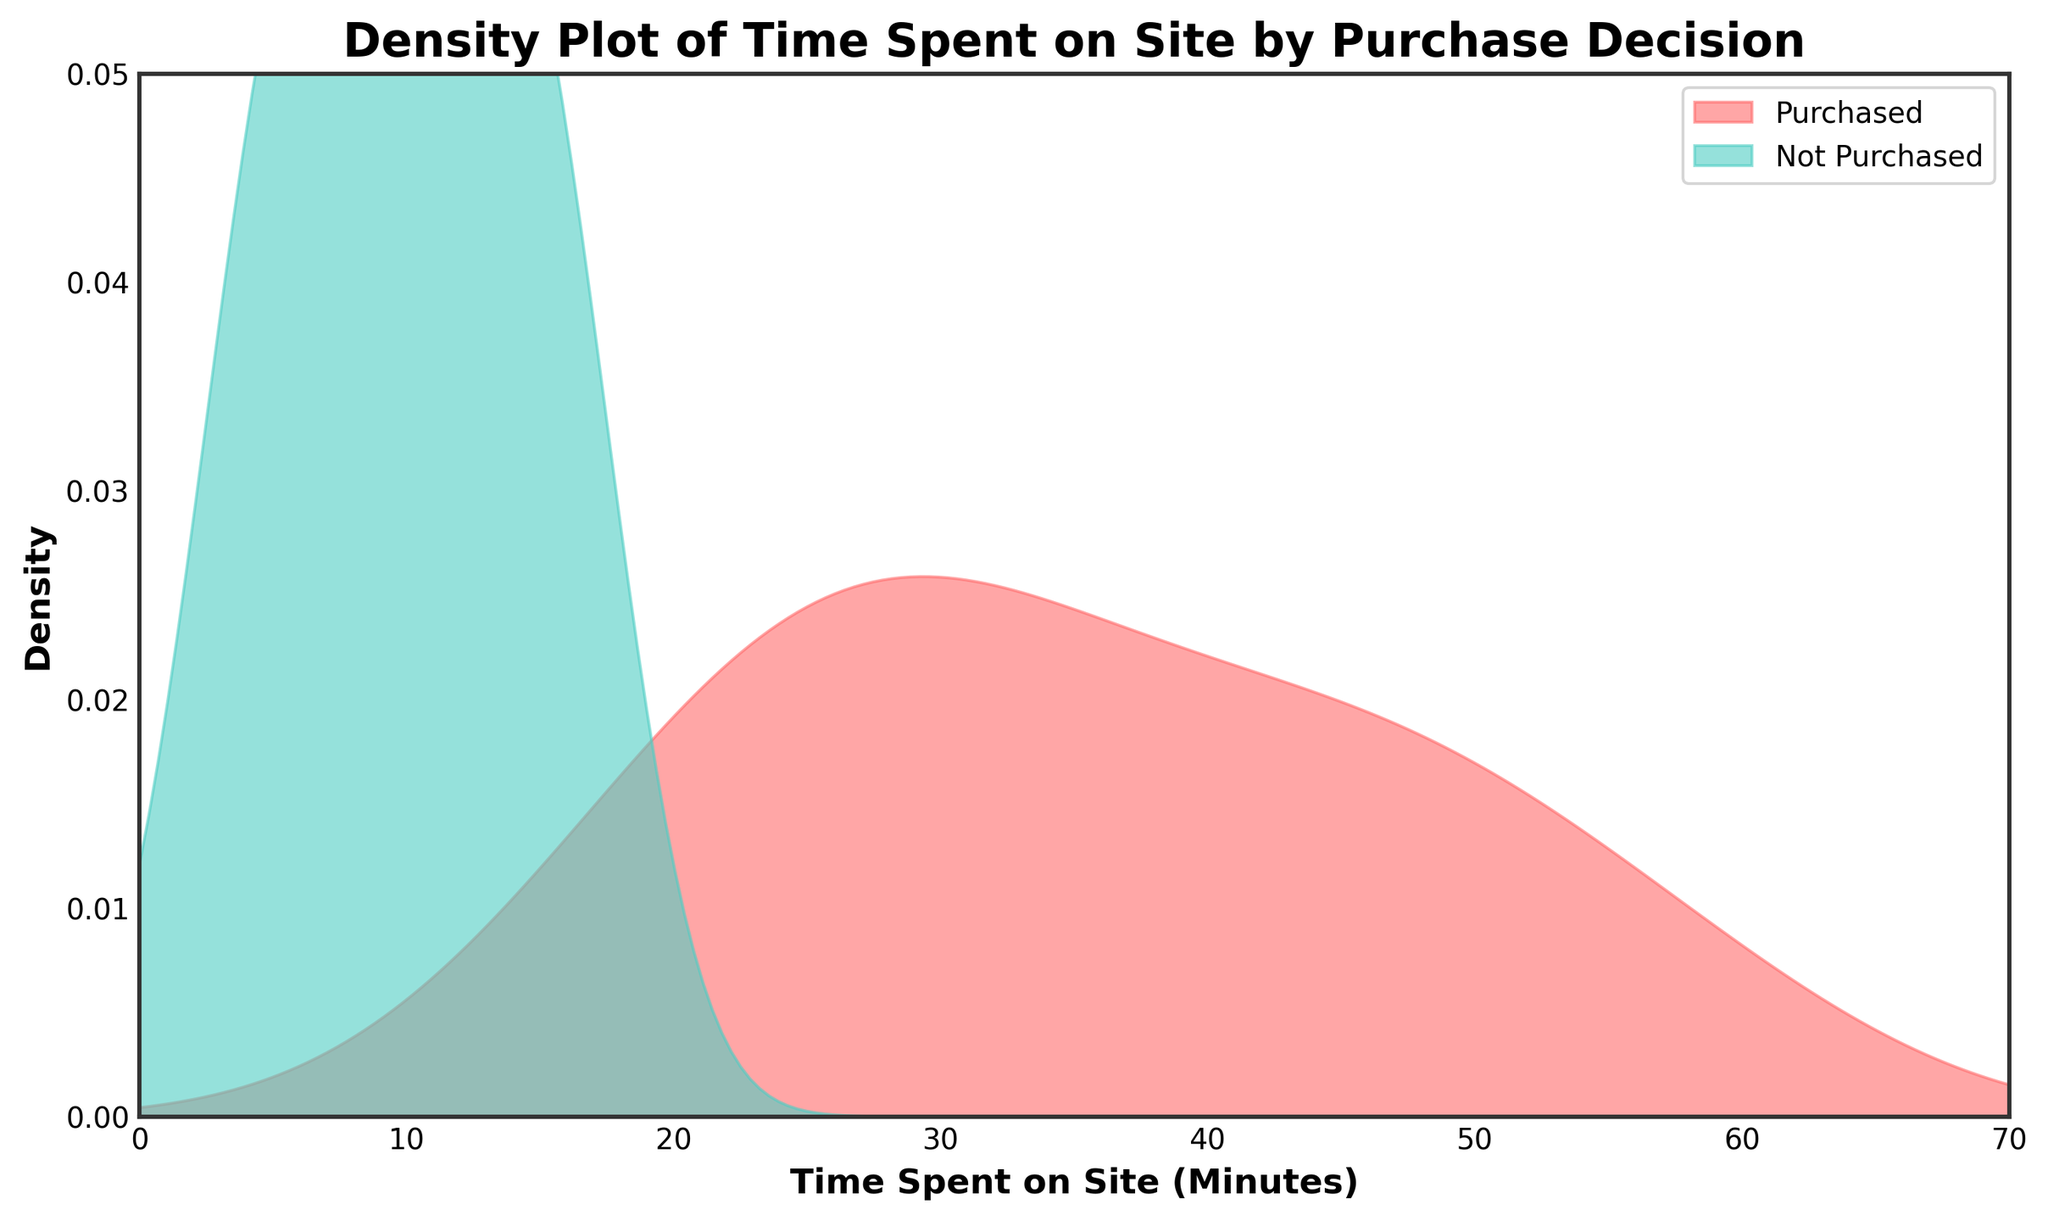What is the title of the figure? The title of the figure is shown at the top of the plot. It is displayed in a larger, bold font to easily catch the viewer's attention.
Answer: Density Plot of Time Spent on Site by Purchase Decision Which group has a higher density for time spent between 30 and 50 minutes? By examining the overlapping areas between the two density plots, the red area (Purchased) has a higher density between 30 and 50 minutes compared to the green area (Not Purchased).
Answer: Purchased What does the x-axis represent? The x-axis at the bottom of the plot is labeled 'Time Spent on Site (Minutes)', indicating it measures the time customers spent on the site in minutes.
Answer: Time Spent on Site (Minutes) What does the y-axis represent? The y-axis on the left side of the plot is labeled 'Density', which indicates the probability density of the time spent on-site data.
Answer: Density Are the densities of purchased and not purchased overlapping in the range of 15 to 25 minutes? Observing the two density curves in the specified range, it is clear that the densities for both Purchased (red) and Not Purchased (green) overlap between 15 and 25 minutes.
Answer: Yes Which time interval has the peak density for the Purchased group? The peak of the density curve for the Purchased group (red) can be seen visually. By glancing at the plot, it lies roughly in the range of 15 to 25 minutes.
Answer: 15 to 25 minutes Which color represents the Not Purchased group in the plot? The legend in the top-right corner indicates that the color green represents the Not Purchased group.
Answer: Green At what time spent does the density for the Purchased group start to decline? The density for the Purchased group (red) starts to decline after observing the peak which occurs roughly between 15 to 25 minutes. Post this range, the density begins to decrease.
Answer: After 25 minutes How are the densities for Purchased and Not Purchased different at around 5 minutes? By looking at the density curves around the 5-minute mark, the green curve (Not Purchased) shows a peak, whereas the red curve (Purchased) is significantly lower.
Answer: The density for Not Purchased is higher What is the approximate maximum density value observed on the y-axis? The highest point on the y-axis can be estimated by looking at the top of both density curves. The maximum value is approximately between 0.03 and 0.04.
Answer: Between 0.03 and 0.04 